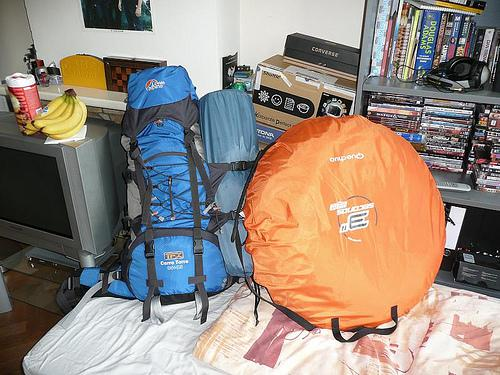Question: what color is the thing next to the backpack?
Choices:
A. Purple.
B. Green.
C. Red.
D. Orange.
Answer with the letter. Answer: D Question: what color are the walls?
Choices:
A. White.
B. Black.
C. Blue.
D. Tan.
Answer with the letter. Answer: A Question: who is standing next to the desk?
Choices:
A. Everyone.
B. The family.
C. The dogs.
D. No one.
Answer with the letter. Answer: D Question: how many men are in this photo?
Choices:
A. One.
B. Two.
C. Zero.
D. Three.
Answer with the letter. Answer: C Question: what are the objects in the bookcase behind the orange thing?
Choices:
A. Tapes.
B. Videos.
C. DVDs.
D. Cassettes.
Answer with the letter. Answer: C Question: what food object is on the desk on the far left?
Choices:
A. Carrots.
B. Peanuts.
C. Milk.
D. Bananas.
Answer with the letter. Answer: D Question: where was this photo taken?
Choices:
A. At a hospital.
B. In a house.
C. In a hotel room.
D. In the woods.
Answer with the letter. Answer: B Question: what color is the backpack?
Choices:
A. Green.
B. Red.
C. Blue.
D. Silver.
Answer with the letter. Answer: C 